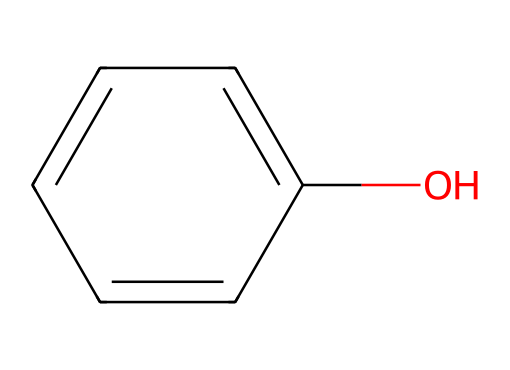What type of chemical compound is represented here? The structure indicates the presence of a hydroxyl (-OH) group attached to an aromatic ring (the benzene ring), which defines it as a phenolic compound.
Answer: phenolic How many carbon atoms are in the molecule? Counting the carbon atoms in the benzene ring, there are six carbon atoms (c1ccccc1 has six 'c' symbols).
Answer: six How many hydrogen atoms are bonded to carbon in this molecule? In the structure, each of the five carbons in the benzene ring has one hydrogen bonded to it, and the carbon bonded to the -OH replaces one hydrogen, totaling six hydrogen atoms.
Answer: six What functional group is present in this compound? The -OH group is a defining feature of phenolic compounds, thus identifying the functional group as a hydroxyl group.
Answer: hydroxyl What property does the presence of the hydroxyl group indicate? The hydroxyl group in phenolic compounds typically indicates that the compound is likely to be more polar, which affects its solubility and reactivity.
Answer: polar Which historical use does this compound relate to in the context of inks? The phenolic compound was likely used in inks due to its stability, color, and adhesive properties, commonly applied in early 20th-century printing.
Answer: stability 